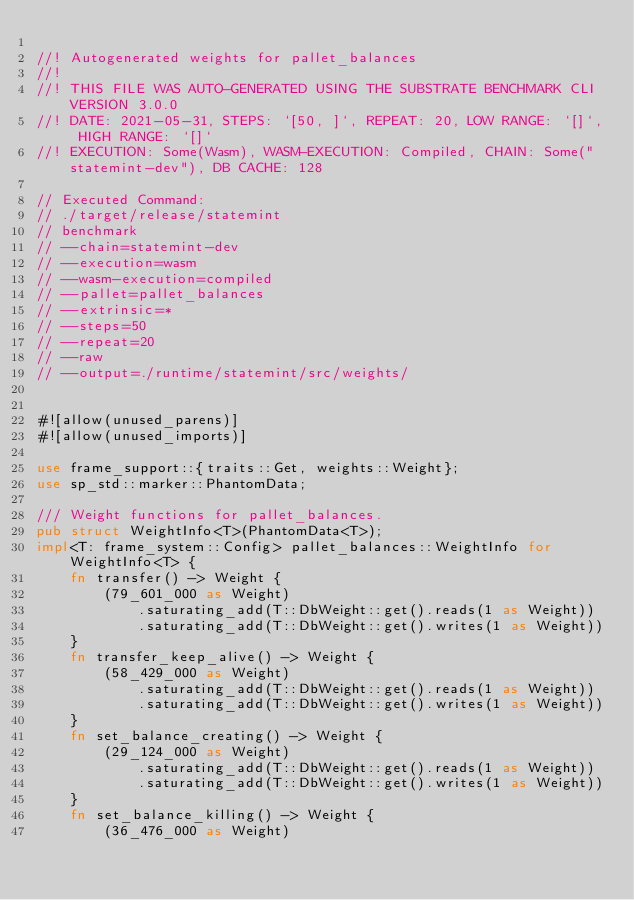Convert code to text. <code><loc_0><loc_0><loc_500><loc_500><_Rust_>
//! Autogenerated weights for pallet_balances
//!
//! THIS FILE WAS AUTO-GENERATED USING THE SUBSTRATE BENCHMARK CLI VERSION 3.0.0
//! DATE: 2021-05-31, STEPS: `[50, ]`, REPEAT: 20, LOW RANGE: `[]`, HIGH RANGE: `[]`
//! EXECUTION: Some(Wasm), WASM-EXECUTION: Compiled, CHAIN: Some("statemint-dev"), DB CACHE: 128

// Executed Command:
// ./target/release/statemint
// benchmark
// --chain=statemint-dev
// --execution=wasm
// --wasm-execution=compiled
// --pallet=pallet_balances
// --extrinsic=*
// --steps=50
// --repeat=20
// --raw
// --output=./runtime/statemint/src/weights/


#![allow(unused_parens)]
#![allow(unused_imports)]

use frame_support::{traits::Get, weights::Weight};
use sp_std::marker::PhantomData;

/// Weight functions for pallet_balances.
pub struct WeightInfo<T>(PhantomData<T>);
impl<T: frame_system::Config> pallet_balances::WeightInfo for WeightInfo<T> {
	fn transfer() -> Weight {
		(79_601_000 as Weight)
			.saturating_add(T::DbWeight::get().reads(1 as Weight))
			.saturating_add(T::DbWeight::get().writes(1 as Weight))
	}
	fn transfer_keep_alive() -> Weight {
		(58_429_000 as Weight)
			.saturating_add(T::DbWeight::get().reads(1 as Weight))
			.saturating_add(T::DbWeight::get().writes(1 as Weight))
	}
	fn set_balance_creating() -> Weight {
		(29_124_000 as Weight)
			.saturating_add(T::DbWeight::get().reads(1 as Weight))
			.saturating_add(T::DbWeight::get().writes(1 as Weight))
	}
	fn set_balance_killing() -> Weight {
		(36_476_000 as Weight)</code> 